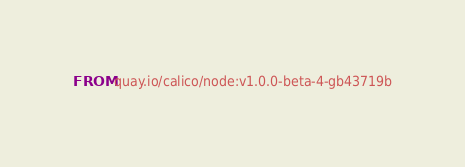<code> <loc_0><loc_0><loc_500><loc_500><_Dockerfile_>FROM quay.io/calico/node:v1.0.0-beta-4-gb43719b
</code> 